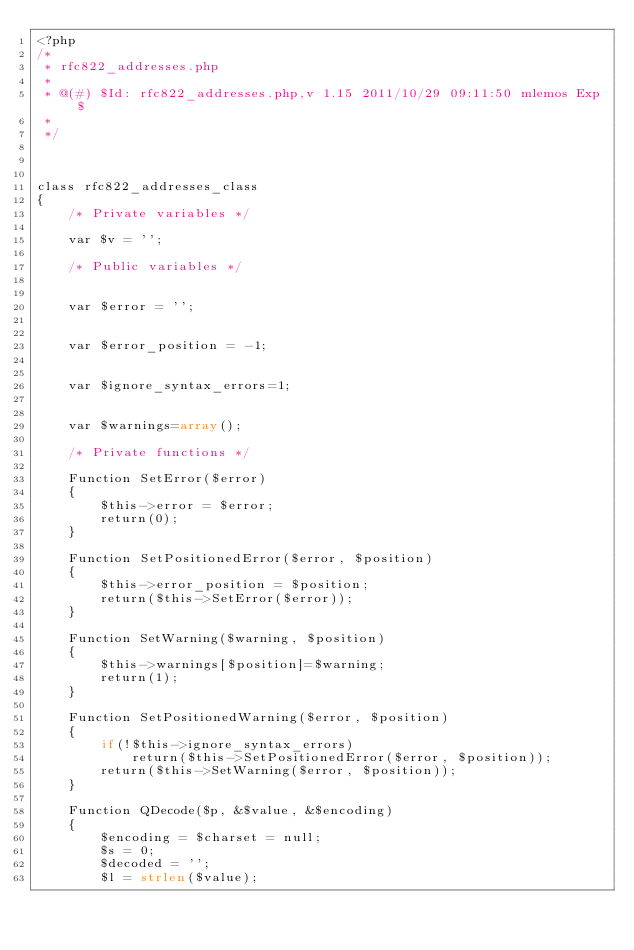Convert code to text. <code><loc_0><loc_0><loc_500><loc_500><_PHP_><?php
/*
 * rfc822_addresses.php
 *
 * @(#) $Id: rfc822_addresses.php,v 1.15 2011/10/29 09:11:50 mlemos Exp $
 *
 */



class rfc822_addresses_class
{
	/* Private variables */

	var $v = '';

	/* Public variables */


	var $error = '';


	var $error_position = -1;


	var $ignore_syntax_errors=1;


	var $warnings=array();

	/* Private functions */

	Function SetError($error)
	{
		$this->error = $error;
		return(0);
	}

	Function SetPositionedError($error, $position)
	{
		$this->error_position = $position;
		return($this->SetError($error));
	}

	Function SetWarning($warning, $position)
	{
		$this->warnings[$position]=$warning;
		return(1);
	}

	Function SetPositionedWarning($error, $position)
	{
		if(!$this->ignore_syntax_errors)
			return($this->SetPositionedError($error, $position));
		return($this->SetWarning($error, $position));
	}

	Function QDecode($p, &$value, &$encoding)
	{
		$encoding = $charset = null;
		$s = 0;
		$decoded = '';
		$l = strlen($value);</code> 